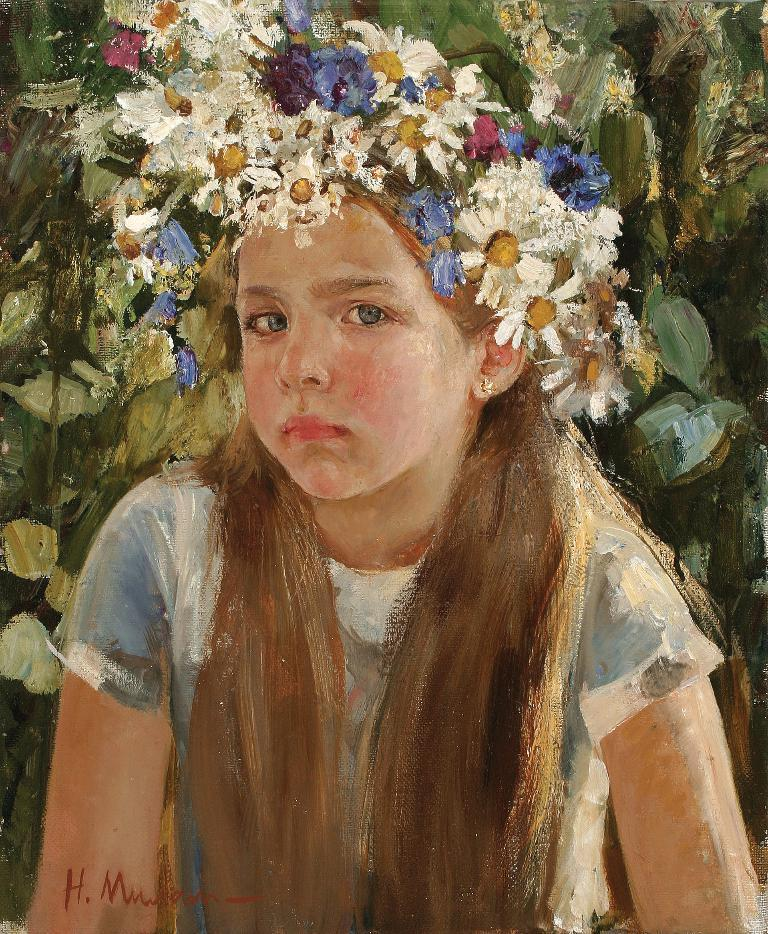What type of artwork is depicted in the image? The image is a painting. Who or what is the main subject of the painting? There is a girl in the painting. What other elements can be seen in the painting? There are flowers and plants in the painting. What color is the balloon held by the girl in the painting? There is no balloon present in the painting; the girl is not holding a balloon. 